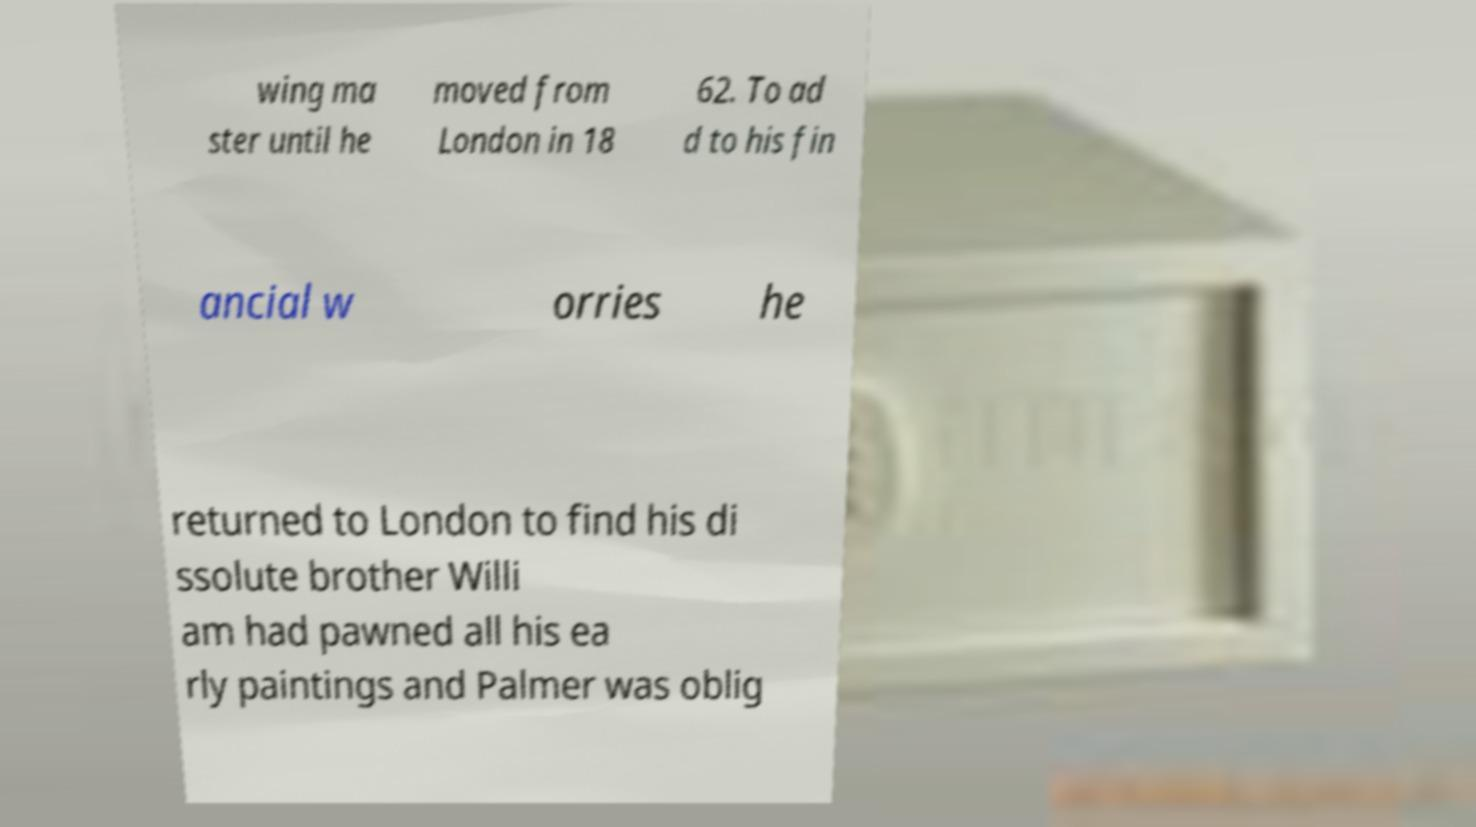For documentation purposes, I need the text within this image transcribed. Could you provide that? wing ma ster until he moved from London in 18 62. To ad d to his fin ancial w orries he returned to London to find his di ssolute brother Willi am had pawned all his ea rly paintings and Palmer was oblig 